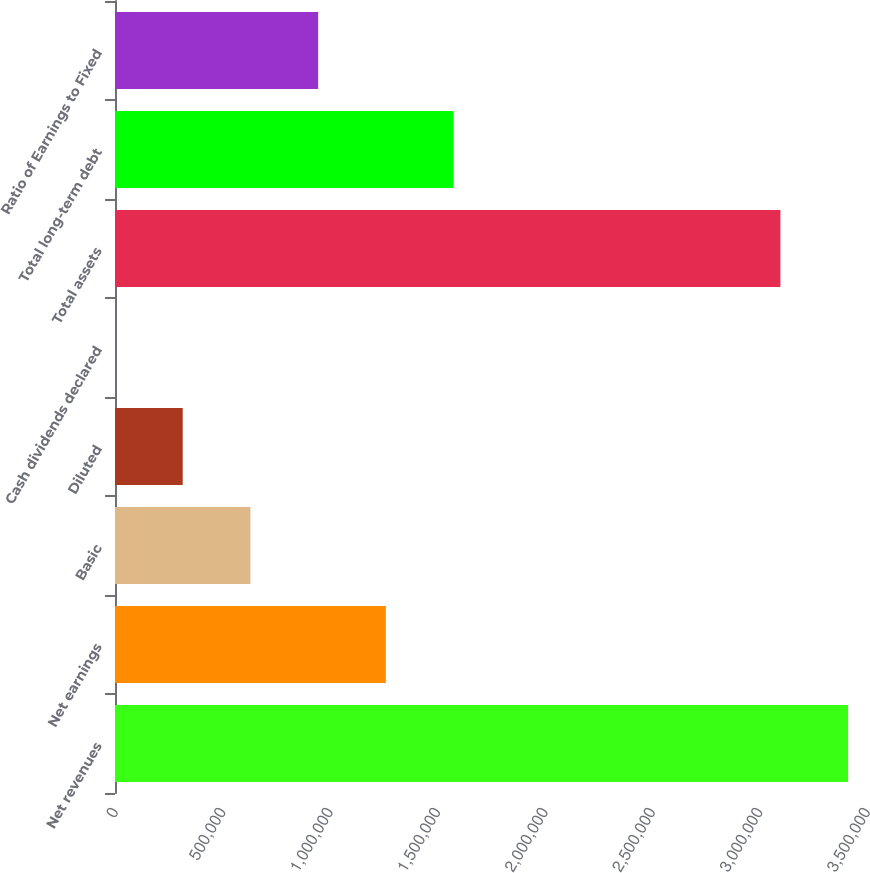Convert chart to OTSL. <chart><loc_0><loc_0><loc_500><loc_500><bar_chart><fcel>Net revenues<fcel>Net earnings<fcel>Basic<fcel>Diluted<fcel>Cash dividends declared<fcel>Total assets<fcel>Total long-term debt<fcel>Ratio of Earnings to Fixed<nl><fcel>3.41205e+06<fcel>1.26059e+06<fcel>630297<fcel>315149<fcel>0.48<fcel>3.0969e+06<fcel>1.57574e+06<fcel>945445<nl></chart> 